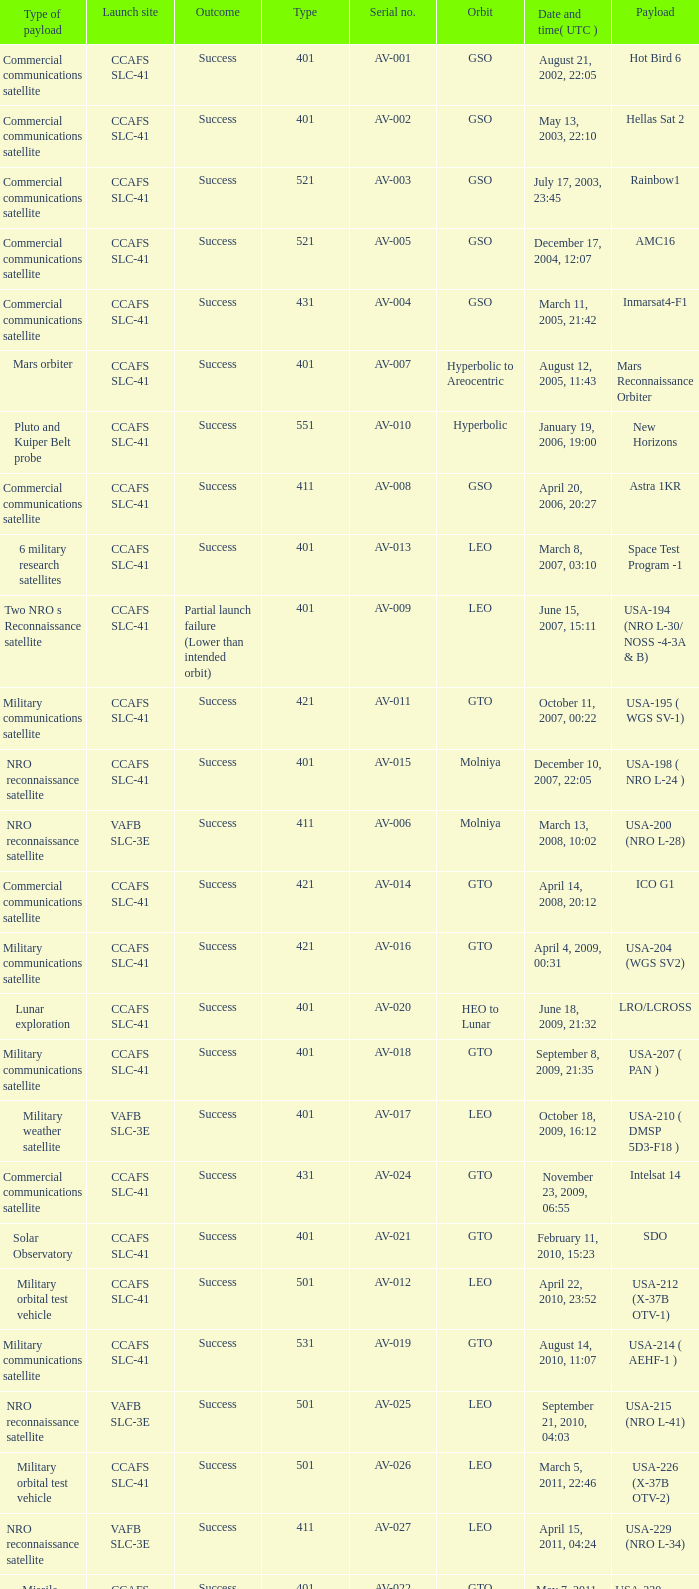For the payload of Van Allen Belts Exploration what's the serial number? AV-032. 